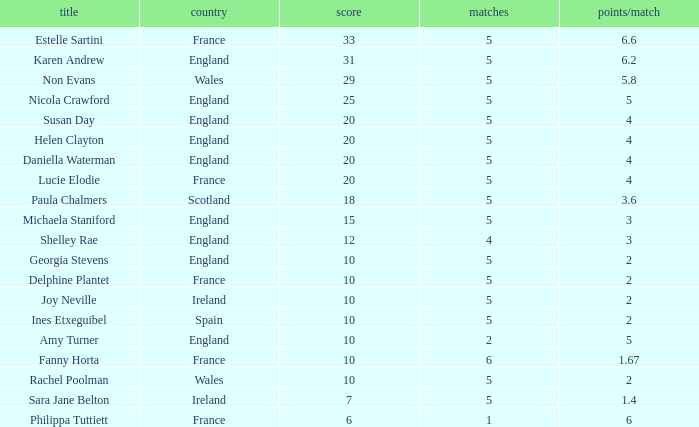Can you tell me the lowest Games that has the Pts/game larger than 1.4 and the Points of 20, and the Name of susan day? 5.0. 